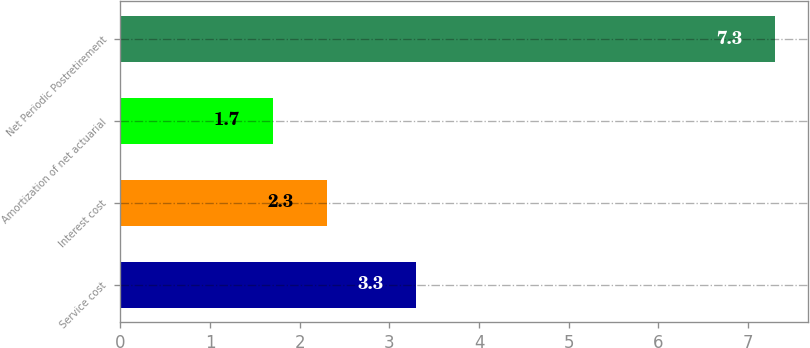Convert chart to OTSL. <chart><loc_0><loc_0><loc_500><loc_500><bar_chart><fcel>Service cost<fcel>Interest cost<fcel>Amortization of net actuarial<fcel>Net Periodic Postretirement<nl><fcel>3.3<fcel>2.3<fcel>1.7<fcel>7.3<nl></chart> 